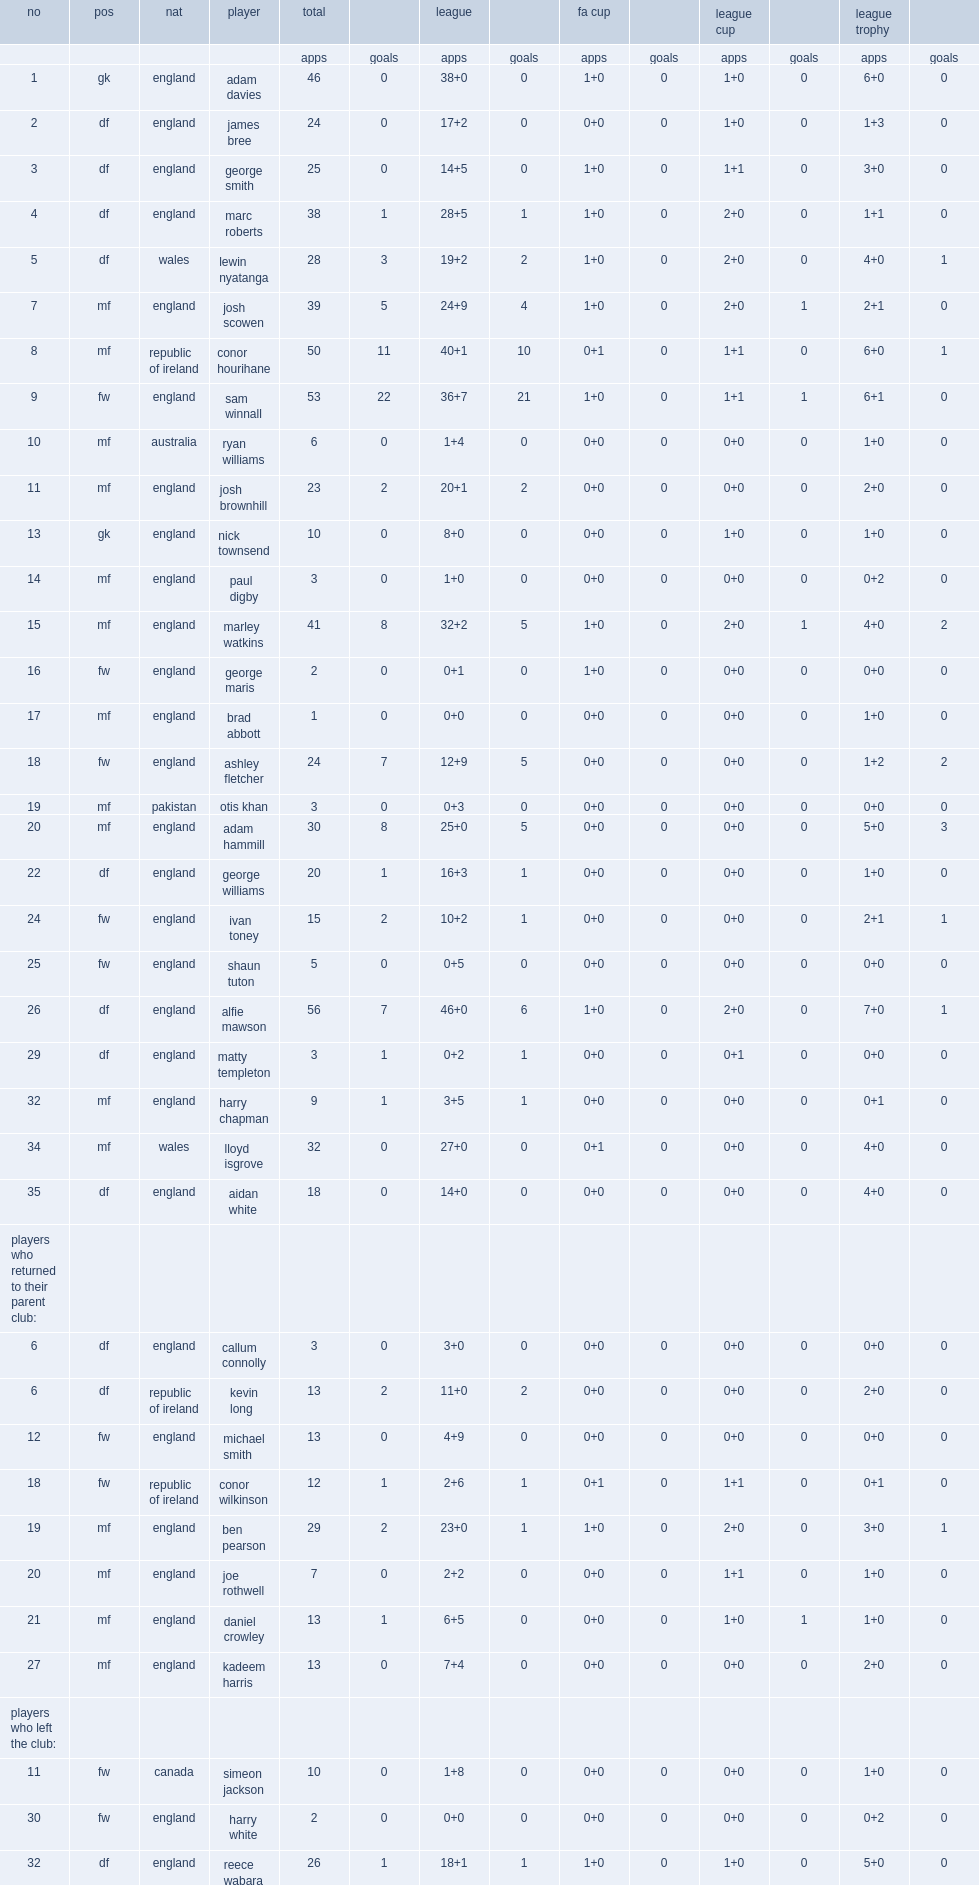Along with league, what are the other games that barnsley f.c. compete in? Fa cup league trophy league cup. Could you help me parse every detail presented in this table? {'header': ['no', 'pos', 'nat', 'player', 'total', '', 'league', '', 'fa cup', '', 'league cup', '', 'league trophy', ''], 'rows': [['', '', '', '', 'apps', 'goals', 'apps', 'goals', 'apps', 'goals', 'apps', 'goals', 'apps', 'goals'], ['1', 'gk', 'england', 'adam davies', '46', '0', '38+0', '0', '1+0', '0', '1+0', '0', '6+0', '0'], ['2', 'df', 'england', 'james bree', '24', '0', '17+2', '0', '0+0', '0', '1+0', '0', '1+3', '0'], ['3', 'df', 'england', 'george smith', '25', '0', '14+5', '0', '1+0', '0', '1+1', '0', '3+0', '0'], ['4', 'df', 'england', 'marc roberts', '38', '1', '28+5', '1', '1+0', '0', '2+0', '0', '1+1', '0'], ['5', 'df', 'wales', 'lewin nyatanga', '28', '3', '19+2', '2', '1+0', '0', '2+0', '0', '4+0', '1'], ['7', 'mf', 'england', 'josh scowen', '39', '5', '24+9', '4', '1+0', '0', '2+0', '1', '2+1', '0'], ['8', 'mf', 'republic of ireland', 'conor hourihane', '50', '11', '40+1', '10', '0+1', '0', '1+1', '0', '6+0', '1'], ['9', 'fw', 'england', 'sam winnall', '53', '22', '36+7', '21', '1+0', '0', '1+1', '1', '6+1', '0'], ['10', 'mf', 'australia', 'ryan williams', '6', '0', '1+4', '0', '0+0', '0', '0+0', '0', '1+0', '0'], ['11', 'mf', 'england', 'josh brownhill', '23', '2', '20+1', '2', '0+0', '0', '0+0', '0', '2+0', '0'], ['13', 'gk', 'england', 'nick townsend', '10', '0', '8+0', '0', '0+0', '0', '1+0', '0', '1+0', '0'], ['14', 'mf', 'england', 'paul digby', '3', '0', '1+0', '0', '0+0', '0', '0+0', '0', '0+2', '0'], ['15', 'mf', 'england', 'marley watkins', '41', '8', '32+2', '5', '1+0', '0', '2+0', '1', '4+0', '2'], ['16', 'fw', 'england', 'george maris', '2', '0', '0+1', '0', '1+0', '0', '0+0', '0', '0+0', '0'], ['17', 'mf', 'england', 'brad abbott', '1', '0', '0+0', '0', '0+0', '0', '0+0', '0', '1+0', '0'], ['18', 'fw', 'england', 'ashley fletcher', '24', '7', '12+9', '5', '0+0', '0', '0+0', '0', '1+2', '2'], ['19', 'mf', 'pakistan', 'otis khan', '3', '0', '0+3', '0', '0+0', '0', '0+0', '0', '0+0', '0'], ['20', 'mf', 'england', 'adam hammill', '30', '8', '25+0', '5', '0+0', '0', '0+0', '0', '5+0', '3'], ['22', 'df', 'england', 'george williams', '20', '1', '16+3', '1', '0+0', '0', '0+0', '0', '1+0', '0'], ['24', 'fw', 'england', 'ivan toney', '15', '2', '10+2', '1', '0+0', '0', '0+0', '0', '2+1', '1'], ['25', 'fw', 'england', 'shaun tuton', '5', '0', '0+5', '0', '0+0', '0', '0+0', '0', '0+0', '0'], ['26', 'df', 'england', 'alfie mawson', '56', '7', '46+0', '6', '1+0', '0', '2+0', '0', '7+0', '1'], ['29', 'df', 'england', 'matty templeton', '3', '1', '0+2', '1', '0+0', '0', '0+1', '0', '0+0', '0'], ['32', 'mf', 'england', 'harry chapman', '9', '1', '3+5', '1', '0+0', '0', '0+0', '0', '0+1', '0'], ['34', 'mf', 'wales', 'lloyd isgrove', '32', '0', '27+0', '0', '0+1', '0', '0+0', '0', '4+0', '0'], ['35', 'df', 'england', 'aidan white', '18', '0', '14+0', '0', '0+0', '0', '0+0', '0', '4+0', '0'], ['players who returned to their parent club:', '', '', '', '', '', '', '', '', '', '', '', '', ''], ['6', 'df', 'england', 'callum connolly', '3', '0', '3+0', '0', '0+0', '0', '0+0', '0', '0+0', '0'], ['6', 'df', 'republic of ireland', 'kevin long', '13', '2', '11+0', '2', '0+0', '0', '0+0', '0', '2+0', '0'], ['12', 'fw', 'england', 'michael smith', '13', '0', '4+9', '0', '0+0', '0', '0+0', '0', '0+0', '0'], ['18', 'fw', 'republic of ireland', 'conor wilkinson', '12', '1', '2+6', '1', '0+1', '0', '1+1', '0', '0+1', '0'], ['19', 'mf', 'england', 'ben pearson', '29', '2', '23+0', '1', '1+0', '0', '2+0', '0', '3+0', '1'], ['20', 'mf', 'england', 'joe rothwell', '7', '0', '2+2', '0', '0+0', '0', '1+1', '0', '1+0', '0'], ['21', 'mf', 'england', 'daniel crowley', '13', '1', '6+5', '0', '0+0', '0', '1+0', '1', '1+0', '0'], ['27', 'mf', 'england', 'kadeem harris', '13', '0', '7+4', '0', '0+0', '0', '0+0', '0', '2+0', '0'], ['players who left the club:', '', '', '', '', '', '', '', '', '', '', '', '', ''], ['11', 'fw', 'canada', 'simeon jackson', '10', '0', '1+8', '0', '0+0', '0', '0+0', '0', '1+0', '0'], ['30', 'fw', 'england', 'harry white', '2', '0', '0+0', '0', '0+0', '0', '0+0', '0', '0+2', '0'], ['32', 'df', 'england', 'reece wabara', '26', '1', '18+1', '1', '1+0', '0', '1+0', '0', '5+0', '0']]} 